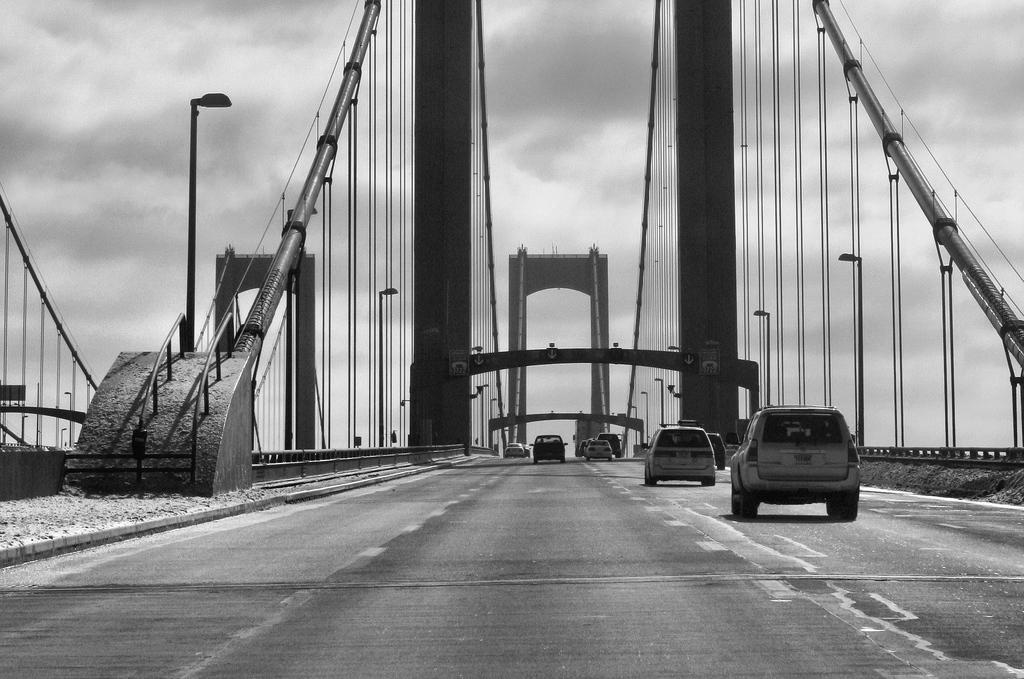What can be seen on the road in the image? There are vehicles on the road in the image. What is visible in the background of the image? There are street lights, wires, a bridge, and the sky visible in the background of the image. What is the color scheme of the image? The image is black and white in color. What type of meat is being sold by the crook in the image? There is no crook or meat present in the image. What time of day is it in the image, based on the hour? The image is black and white, and there is no indication of time or hour in the image. 